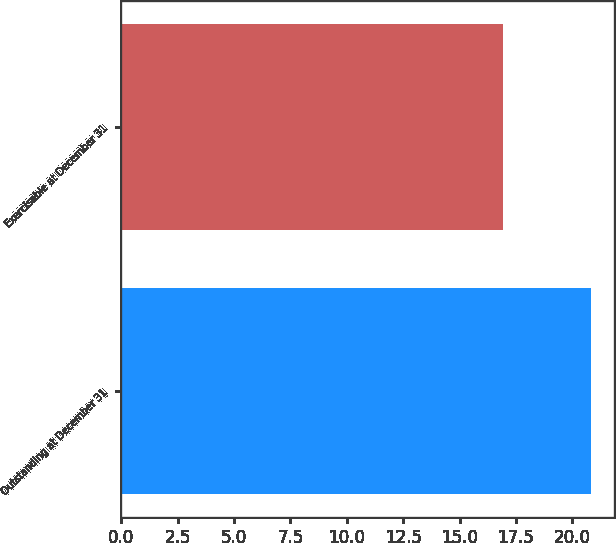Convert chart to OTSL. <chart><loc_0><loc_0><loc_500><loc_500><bar_chart><fcel>Outstanding at December 31<fcel>Exercisable at December 31<nl><fcel>20.81<fcel>16.94<nl></chart> 